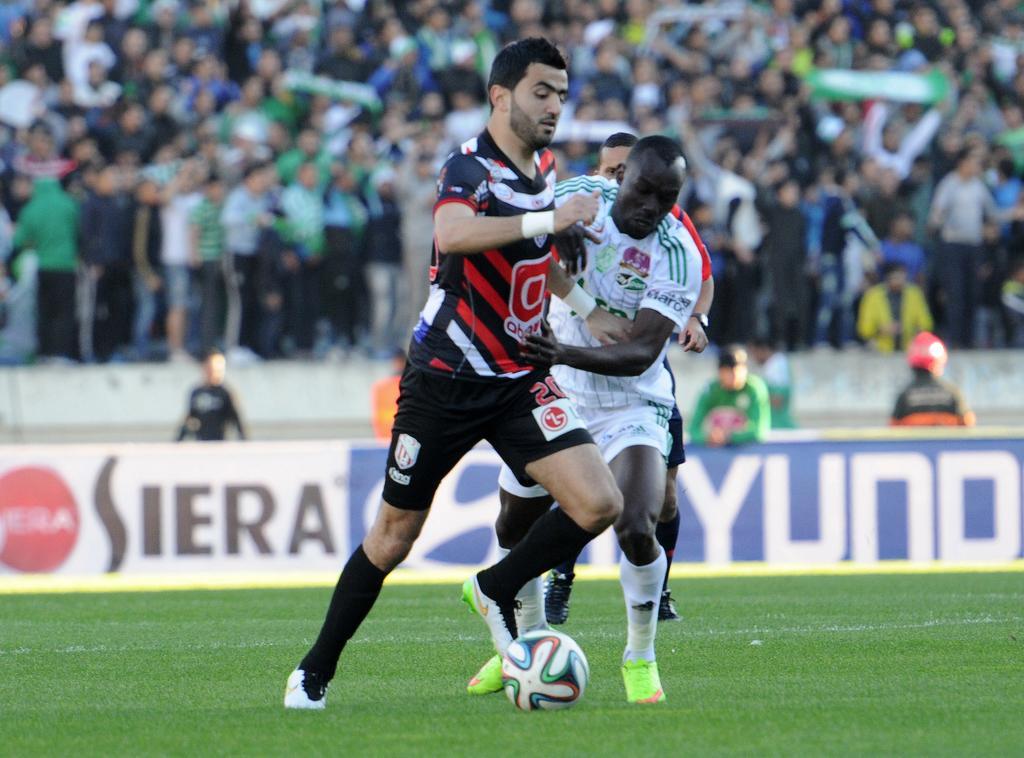Describe this image in one or two sentences. In the image the players are playing football in the ground and behind the ground there are spectators watching the match. 